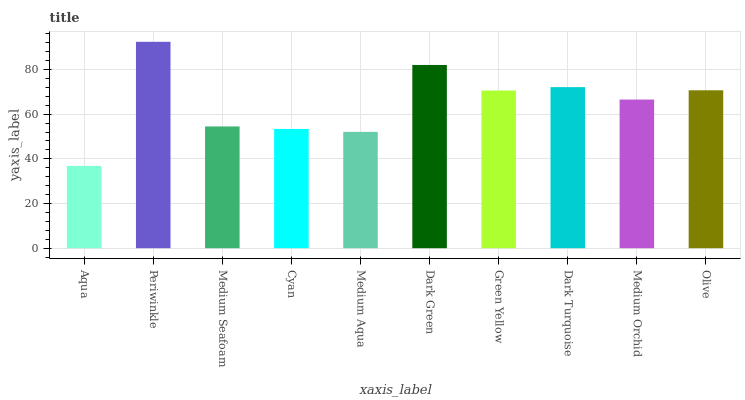Is Medium Seafoam the minimum?
Answer yes or no. No. Is Medium Seafoam the maximum?
Answer yes or no. No. Is Periwinkle greater than Medium Seafoam?
Answer yes or no. Yes. Is Medium Seafoam less than Periwinkle?
Answer yes or no. Yes. Is Medium Seafoam greater than Periwinkle?
Answer yes or no. No. Is Periwinkle less than Medium Seafoam?
Answer yes or no. No. Is Green Yellow the high median?
Answer yes or no. Yes. Is Medium Orchid the low median?
Answer yes or no. Yes. Is Dark Green the high median?
Answer yes or no. No. Is Dark Turquoise the low median?
Answer yes or no. No. 